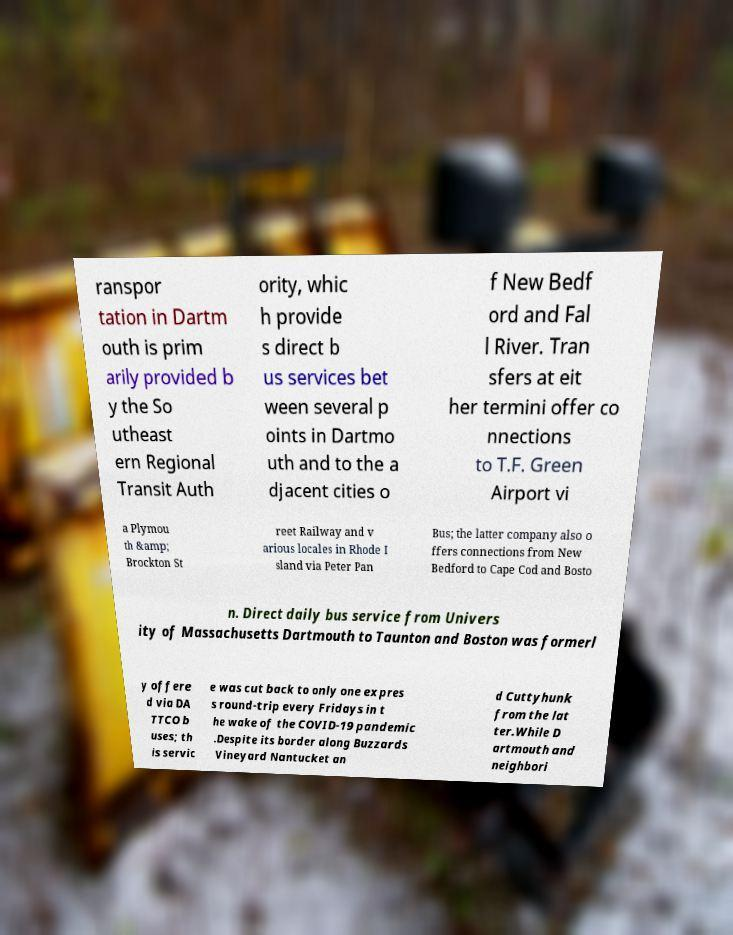For documentation purposes, I need the text within this image transcribed. Could you provide that? ranspor tation in Dartm outh is prim arily provided b y the So utheast ern Regional Transit Auth ority, whic h provide s direct b us services bet ween several p oints in Dartmo uth and to the a djacent cities o f New Bedf ord and Fal l River. Tran sfers at eit her termini offer co nnections to T.F. Green Airport vi a Plymou th &amp; Brockton St reet Railway and v arious locales in Rhode I sland via Peter Pan Bus; the latter company also o ffers connections from New Bedford to Cape Cod and Bosto n. Direct daily bus service from Univers ity of Massachusetts Dartmouth to Taunton and Boston was formerl y offere d via DA TTCO b uses; th is servic e was cut back to only one expres s round-trip every Fridays in t he wake of the COVID-19 pandemic .Despite its border along Buzzards Vineyard Nantucket an d Cuttyhunk from the lat ter.While D artmouth and neighbori 